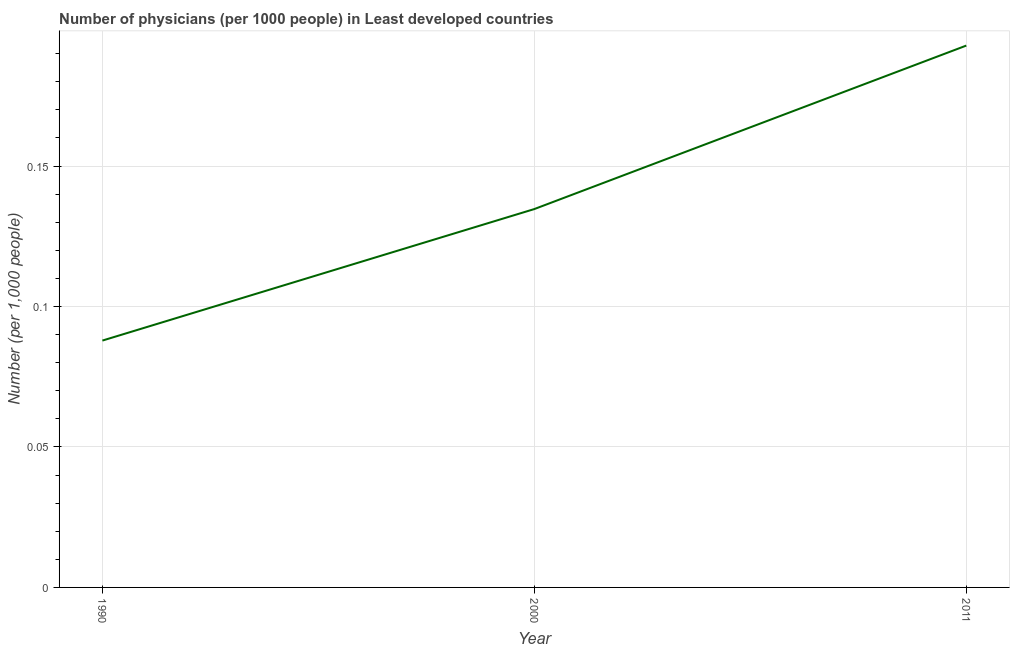What is the number of physicians in 2011?
Your response must be concise. 0.19. Across all years, what is the maximum number of physicians?
Provide a short and direct response. 0.19. Across all years, what is the minimum number of physicians?
Offer a terse response. 0.09. What is the sum of the number of physicians?
Keep it short and to the point. 0.42. What is the difference between the number of physicians in 1990 and 2000?
Your answer should be very brief. -0.05. What is the average number of physicians per year?
Your response must be concise. 0.14. What is the median number of physicians?
Provide a succinct answer. 0.13. In how many years, is the number of physicians greater than 0.14 ?
Give a very brief answer. 1. What is the ratio of the number of physicians in 1990 to that in 2011?
Your answer should be compact. 0.46. Is the difference between the number of physicians in 1990 and 2011 greater than the difference between any two years?
Your answer should be compact. Yes. What is the difference between the highest and the second highest number of physicians?
Provide a short and direct response. 0.06. Is the sum of the number of physicians in 1990 and 2000 greater than the maximum number of physicians across all years?
Keep it short and to the point. Yes. What is the difference between the highest and the lowest number of physicians?
Offer a terse response. 0.11. In how many years, is the number of physicians greater than the average number of physicians taken over all years?
Offer a very short reply. 1. Does the number of physicians monotonically increase over the years?
Provide a short and direct response. Yes. How many years are there in the graph?
Give a very brief answer. 3. What is the difference between two consecutive major ticks on the Y-axis?
Provide a short and direct response. 0.05. Does the graph contain any zero values?
Ensure brevity in your answer.  No. What is the title of the graph?
Your answer should be compact. Number of physicians (per 1000 people) in Least developed countries. What is the label or title of the Y-axis?
Provide a short and direct response. Number (per 1,0 people). What is the Number (per 1,000 people) of 1990?
Provide a succinct answer. 0.09. What is the Number (per 1,000 people) in 2000?
Keep it short and to the point. 0.13. What is the Number (per 1,000 people) of 2011?
Ensure brevity in your answer.  0.19. What is the difference between the Number (per 1,000 people) in 1990 and 2000?
Your response must be concise. -0.05. What is the difference between the Number (per 1,000 people) in 1990 and 2011?
Ensure brevity in your answer.  -0.11. What is the difference between the Number (per 1,000 people) in 2000 and 2011?
Keep it short and to the point. -0.06. What is the ratio of the Number (per 1,000 people) in 1990 to that in 2000?
Your answer should be very brief. 0.65. What is the ratio of the Number (per 1,000 people) in 1990 to that in 2011?
Provide a succinct answer. 0.46. What is the ratio of the Number (per 1,000 people) in 2000 to that in 2011?
Your answer should be compact. 0.7. 